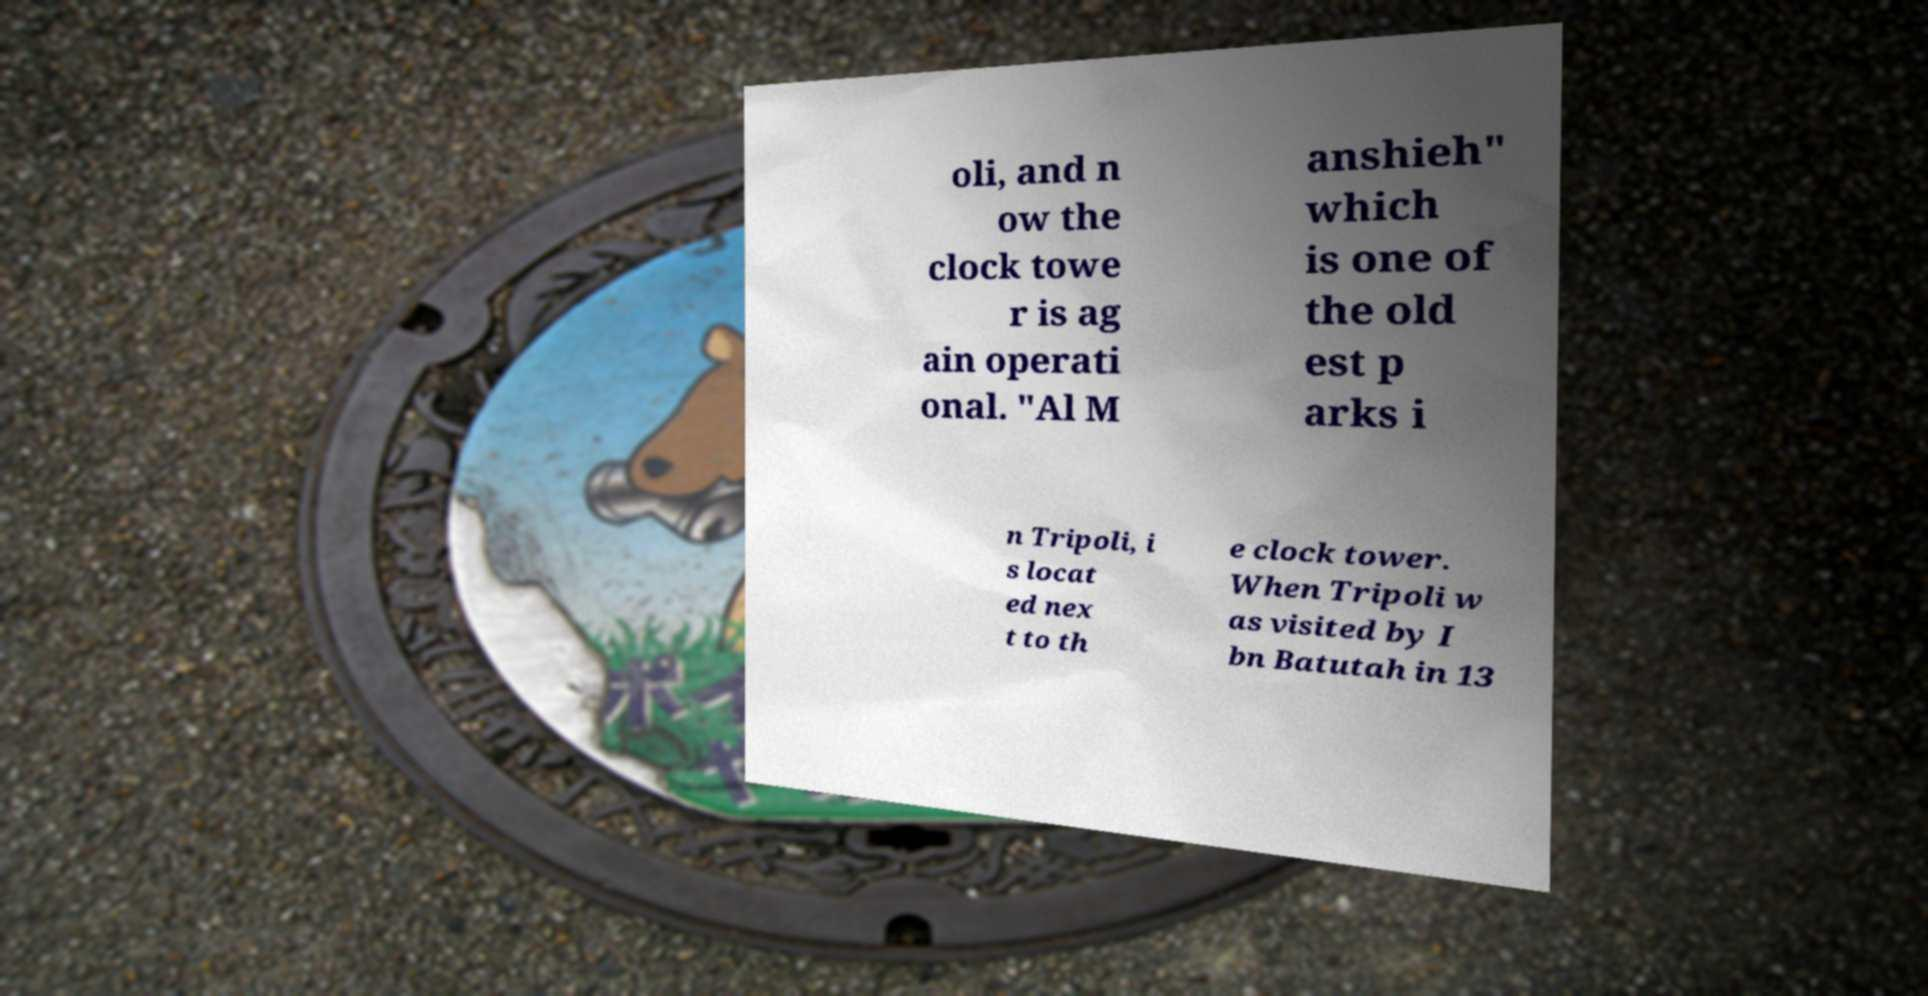Could you assist in decoding the text presented in this image and type it out clearly? oli, and n ow the clock towe r is ag ain operati onal. "Al M anshieh" which is one of the old est p arks i n Tripoli, i s locat ed nex t to th e clock tower. When Tripoli w as visited by I bn Batutah in 13 